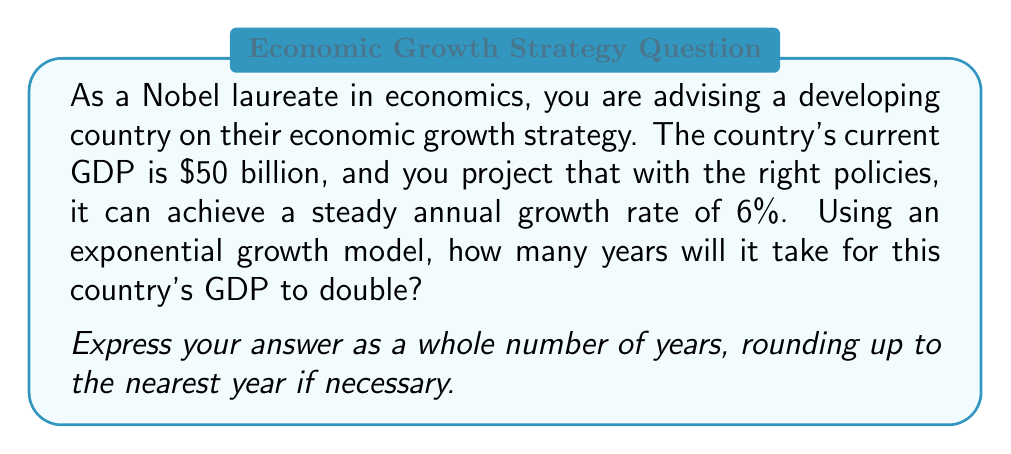Teach me how to tackle this problem. To solve this problem, we'll use the exponential growth model and the concept of doubling time. Let's break it down step-by-step:

1) The exponential growth model is given by the equation:

   $$ A = P(1 + r)^t $$

   Where:
   $A$ is the final amount
   $P$ is the initial principal (in this case, initial GDP)
   $r$ is the annual growth rate (as a decimal)
   $t$ is the time in years

2) We want to find when the GDP doubles, so:

   $$ 2P = P(1 + r)^t $$

3) Simplify by dividing both sides by $P$:

   $$ 2 = (1 + r)^t $$

4) Take the natural log of both sides:

   $$ \ln(2) = t \cdot \ln(1 + r) $$

5) Solve for $t$:

   $$ t = \frac{\ln(2)}{\ln(1 + r)} $$

6) Now, let's plug in our values:
   $r = 0.06$ (6% expressed as a decimal)

   $$ t = \frac{\ln(2)}{\ln(1 + 0.06)} $$

7) Calculate:

   $$ t = \frac{0.6931471806}{0.0582689492} \approx 11.90 \text{ years} $$

8) Rounding up to the nearest year:

   $t = 12$ years

This result is consistent with the "Rule of 72", a quick approximation for doubling time: $72 / 6 = 12$ years.
Answer: 12 years 